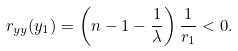Convert formula to latex. <formula><loc_0><loc_0><loc_500><loc_500>r _ { y y } ( y _ { 1 } ) = \left ( n - 1 - \frac { 1 } { \lambda } \right ) \frac { 1 } { r _ { 1 } } < 0 .</formula> 